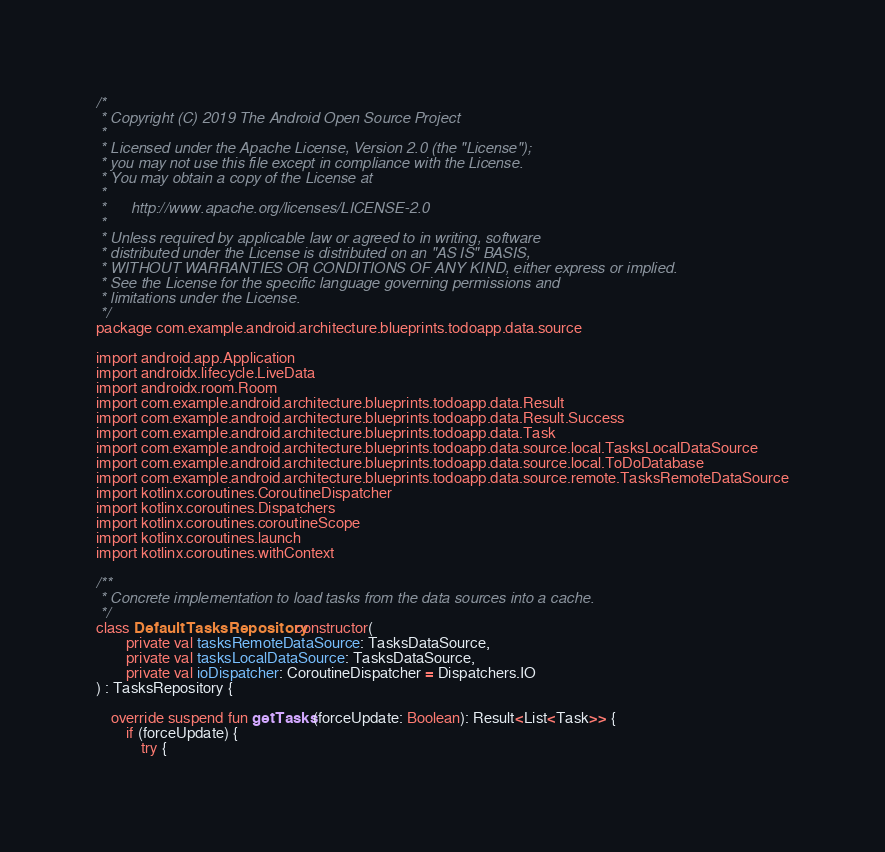<code> <loc_0><loc_0><loc_500><loc_500><_Kotlin_>/*
 * Copyright (C) 2019 The Android Open Source Project
 *
 * Licensed under the Apache License, Version 2.0 (the "License");
 * you may not use this file except in compliance with the License.
 * You may obtain a copy of the License at
 *
 *      http://www.apache.org/licenses/LICENSE-2.0
 *
 * Unless required by applicable law or agreed to in writing, software
 * distributed under the License is distributed on an "AS IS" BASIS,
 * WITHOUT WARRANTIES OR CONDITIONS OF ANY KIND, either express or implied.
 * See the License for the specific language governing permissions and
 * limitations under the License.
 */
package com.example.android.architecture.blueprints.todoapp.data.source

import android.app.Application
import androidx.lifecycle.LiveData
import androidx.room.Room
import com.example.android.architecture.blueprints.todoapp.data.Result
import com.example.android.architecture.blueprints.todoapp.data.Result.Success
import com.example.android.architecture.blueprints.todoapp.data.Task
import com.example.android.architecture.blueprints.todoapp.data.source.local.TasksLocalDataSource
import com.example.android.architecture.blueprints.todoapp.data.source.local.ToDoDatabase
import com.example.android.architecture.blueprints.todoapp.data.source.remote.TasksRemoteDataSource
import kotlinx.coroutines.CoroutineDispatcher
import kotlinx.coroutines.Dispatchers
import kotlinx.coroutines.coroutineScope
import kotlinx.coroutines.launch
import kotlinx.coroutines.withContext

/**
 * Concrete implementation to load tasks from the data sources into a cache.
 */
class DefaultTasksRepository constructor(
        private val tasksRemoteDataSource: TasksDataSource,
        private val tasksLocalDataSource: TasksDataSource,
        private val ioDispatcher: CoroutineDispatcher = Dispatchers.IO
) : TasksRepository {

    override suspend fun getTasks(forceUpdate: Boolean): Result<List<Task>> {
        if (forceUpdate) {
            try {</code> 